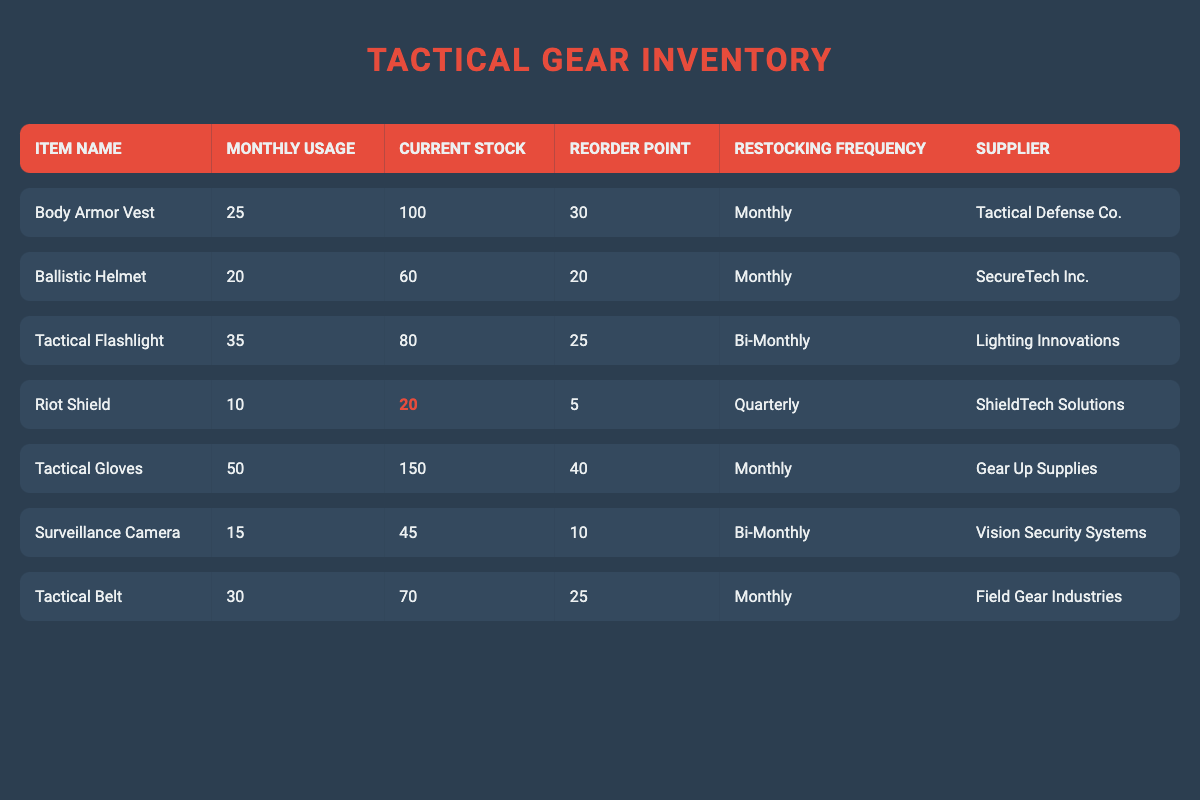What is the current stock of the Tactical Flashlight? The Tactical Flashlight has a current stock of 80 as listed in the table.
Answer: 80 What is the monthly usage of Tactical Gloves? The monthly usage for Tactical Gloves is specified as 50 in the table.
Answer: 50 Is the current stock of the Riot Shield below its reorder point? The current stock of the Riot Shield is 20, and its reorder point is 5. Since 20 is greater than 5, the statement is false.
Answer: No How many items have a monthly usage greater than 30? Analyzing the Monthly Usage column, the Tactical Flashlight (35) and Tactical Gloves (50) exceed 30. Therefore, there are 2 items with a monthly usage greater than 30.
Answer: 2 What is the total monthly usage of all items? Adding the monthly usage for all items: 25 + 20 + 35 + 10 + 50 + 15 + 30 = 185. Therefore, the total monthly usage across all items is 185.
Answer: 185 Is there any item that needs immediate restocking based on the reorder point? The Riot Shield has a current stock of 20 and a reorder point of 5, thus it is not below the reorder point. The Ballistic Helmet also has a current stock of 60, which is above its reorder point of 20. Therefore, no immediate restocking is required.
Answer: No What is the average current stock of the Tactical Gear? The current stocks are 100, 60, 80, 20, 150, 45, and 70. The sum is 525 and with 7 items, the average current stock is 525/7 = 75.
Answer: 75 